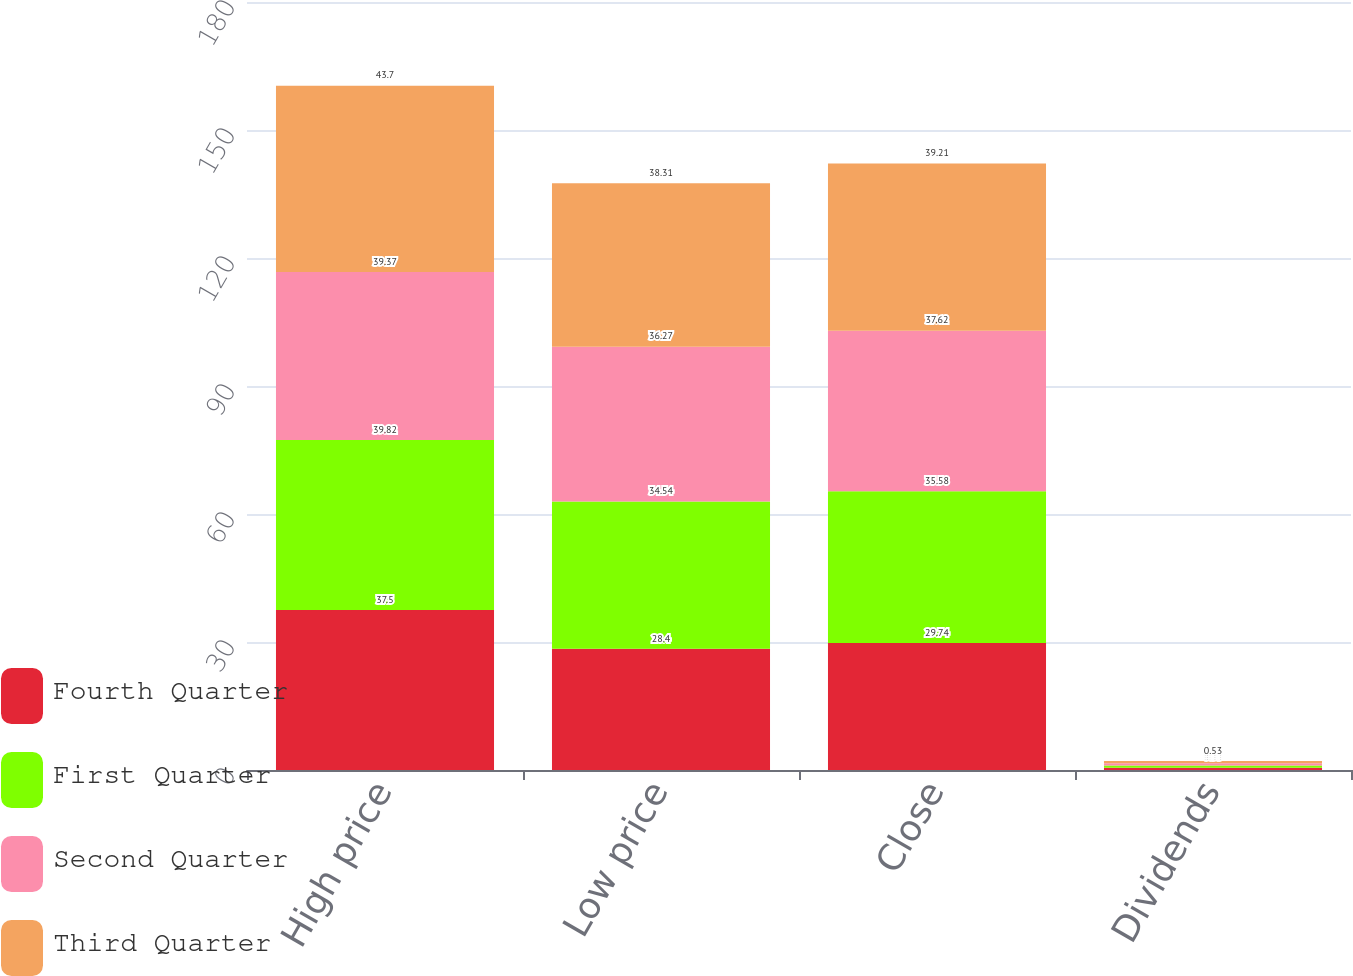Convert chart. <chart><loc_0><loc_0><loc_500><loc_500><stacked_bar_chart><ecel><fcel>High price<fcel>Low price<fcel>Close<fcel>Dividends<nl><fcel>Fourth Quarter<fcel>37.5<fcel>28.4<fcel>29.74<fcel>0.53<nl><fcel>First Quarter<fcel>39.82<fcel>34.54<fcel>35.58<fcel>0.53<nl><fcel>Second Quarter<fcel>39.37<fcel>36.27<fcel>37.62<fcel>0.53<nl><fcel>Third Quarter<fcel>43.7<fcel>38.31<fcel>39.21<fcel>0.53<nl></chart> 